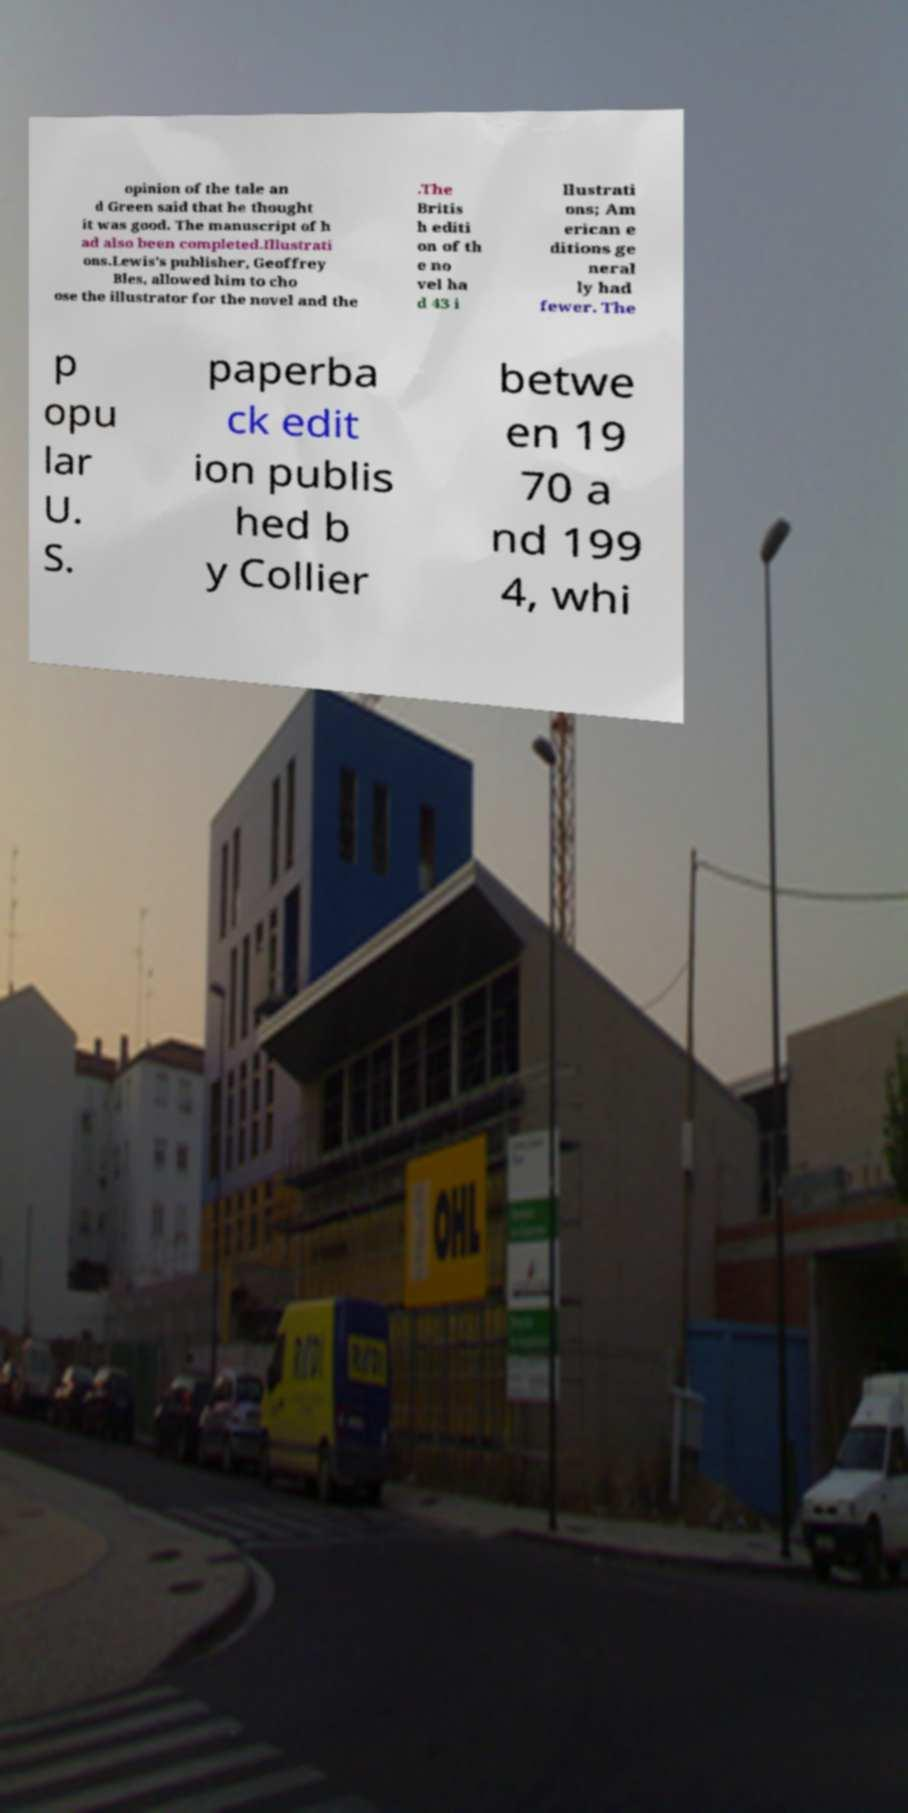Could you extract and type out the text from this image? opinion of the tale an d Green said that he thought it was good. The manuscript of h ad also been completed.Illustrati ons.Lewis's publisher, Geoffrey Bles, allowed him to cho ose the illustrator for the novel and the .The Britis h editi on of th e no vel ha d 43 i llustrati ons; Am erican e ditions ge neral ly had fewer. The p opu lar U. S. paperba ck edit ion publis hed b y Collier betwe en 19 70 a nd 199 4, whi 